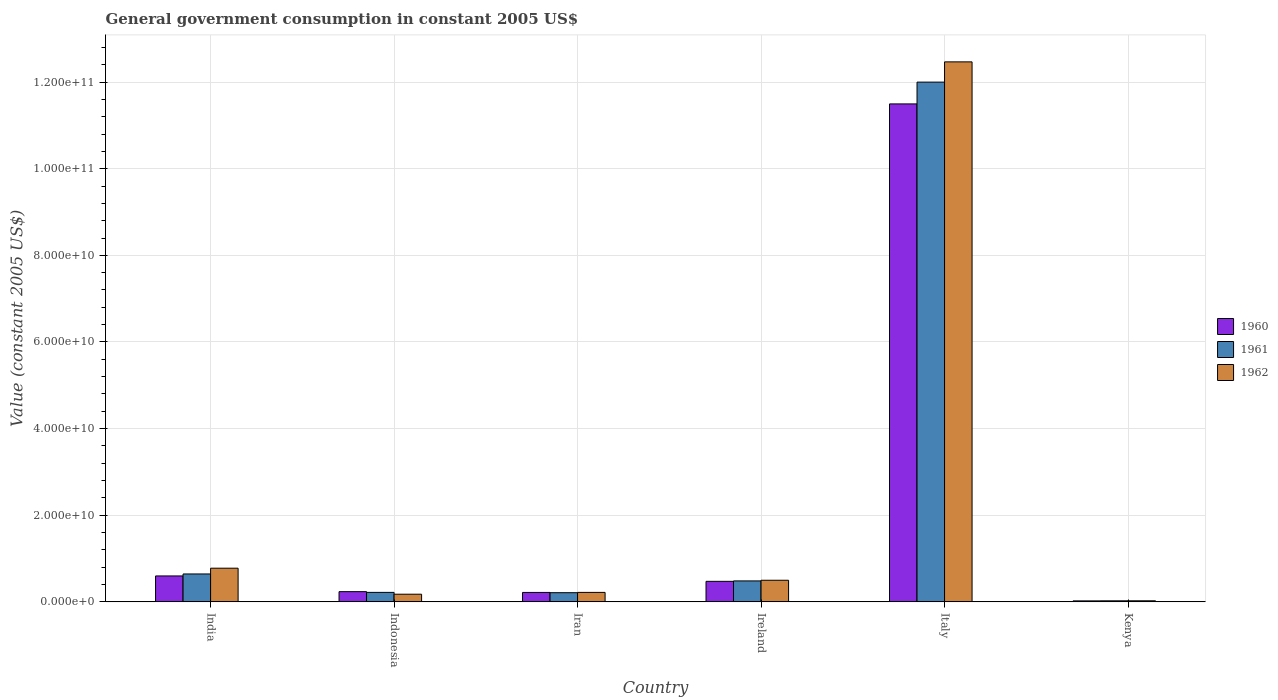How many different coloured bars are there?
Offer a very short reply. 3. How many groups of bars are there?
Your answer should be very brief. 6. Are the number of bars on each tick of the X-axis equal?
Your answer should be very brief. Yes. What is the label of the 4th group of bars from the left?
Keep it short and to the point. Ireland. In how many cases, is the number of bars for a given country not equal to the number of legend labels?
Your response must be concise. 0. What is the government conusmption in 1960 in Kenya?
Your response must be concise. 2.28e+08. Across all countries, what is the maximum government conusmption in 1962?
Offer a terse response. 1.25e+11. Across all countries, what is the minimum government conusmption in 1960?
Offer a terse response. 2.28e+08. In which country was the government conusmption in 1960 maximum?
Offer a terse response. Italy. In which country was the government conusmption in 1960 minimum?
Make the answer very short. Kenya. What is the total government conusmption in 1962 in the graph?
Your response must be concise. 1.42e+11. What is the difference between the government conusmption in 1960 in Iran and that in Ireland?
Your response must be concise. -2.56e+09. What is the difference between the government conusmption in 1962 in Kenya and the government conusmption in 1961 in Ireland?
Offer a terse response. -4.59e+09. What is the average government conusmption in 1962 per country?
Give a very brief answer. 2.36e+1. What is the difference between the government conusmption of/in 1960 and government conusmption of/in 1962 in Italy?
Your answer should be compact. -9.70e+09. What is the ratio of the government conusmption in 1961 in Iran to that in Ireland?
Your answer should be very brief. 0.44. Is the government conusmption in 1961 in Ireland less than that in Kenya?
Offer a terse response. No. Is the difference between the government conusmption in 1960 in India and Italy greater than the difference between the government conusmption in 1962 in India and Italy?
Your answer should be compact. Yes. What is the difference between the highest and the second highest government conusmption in 1961?
Ensure brevity in your answer.  1.14e+11. What is the difference between the highest and the lowest government conusmption in 1960?
Keep it short and to the point. 1.15e+11. In how many countries, is the government conusmption in 1961 greater than the average government conusmption in 1961 taken over all countries?
Make the answer very short. 1. Are all the bars in the graph horizontal?
Your response must be concise. No. What is the difference between two consecutive major ticks on the Y-axis?
Offer a very short reply. 2.00e+1. Does the graph contain grids?
Give a very brief answer. Yes. Where does the legend appear in the graph?
Your answer should be compact. Center right. How many legend labels are there?
Your answer should be compact. 3. What is the title of the graph?
Make the answer very short. General government consumption in constant 2005 US$. What is the label or title of the X-axis?
Keep it short and to the point. Country. What is the label or title of the Y-axis?
Make the answer very short. Value (constant 2005 US$). What is the Value (constant 2005 US$) of 1960 in India?
Offer a terse response. 5.99e+09. What is the Value (constant 2005 US$) of 1961 in India?
Provide a succinct answer. 6.44e+09. What is the Value (constant 2005 US$) of 1962 in India?
Make the answer very short. 7.77e+09. What is the Value (constant 2005 US$) of 1960 in Indonesia?
Keep it short and to the point. 2.36e+09. What is the Value (constant 2005 US$) in 1961 in Indonesia?
Your answer should be compact. 2.19e+09. What is the Value (constant 2005 US$) of 1962 in Indonesia?
Ensure brevity in your answer.  1.77e+09. What is the Value (constant 2005 US$) of 1960 in Iran?
Your response must be concise. 2.18e+09. What is the Value (constant 2005 US$) of 1961 in Iran?
Provide a short and direct response. 2.12e+09. What is the Value (constant 2005 US$) of 1962 in Iran?
Provide a succinct answer. 2.19e+09. What is the Value (constant 2005 US$) in 1960 in Ireland?
Give a very brief answer. 4.74e+09. What is the Value (constant 2005 US$) of 1961 in Ireland?
Make the answer very short. 4.84e+09. What is the Value (constant 2005 US$) in 1962 in Ireland?
Provide a short and direct response. 4.99e+09. What is the Value (constant 2005 US$) of 1960 in Italy?
Your answer should be very brief. 1.15e+11. What is the Value (constant 2005 US$) in 1961 in Italy?
Provide a short and direct response. 1.20e+11. What is the Value (constant 2005 US$) in 1962 in Italy?
Ensure brevity in your answer.  1.25e+11. What is the Value (constant 2005 US$) of 1960 in Kenya?
Offer a terse response. 2.28e+08. What is the Value (constant 2005 US$) in 1961 in Kenya?
Keep it short and to the point. 2.44e+08. What is the Value (constant 2005 US$) of 1962 in Kenya?
Keep it short and to the point. 2.50e+08. Across all countries, what is the maximum Value (constant 2005 US$) in 1960?
Offer a terse response. 1.15e+11. Across all countries, what is the maximum Value (constant 2005 US$) of 1961?
Your response must be concise. 1.20e+11. Across all countries, what is the maximum Value (constant 2005 US$) of 1962?
Provide a succinct answer. 1.25e+11. Across all countries, what is the minimum Value (constant 2005 US$) of 1960?
Your response must be concise. 2.28e+08. Across all countries, what is the minimum Value (constant 2005 US$) in 1961?
Offer a very short reply. 2.44e+08. Across all countries, what is the minimum Value (constant 2005 US$) in 1962?
Your answer should be compact. 2.50e+08. What is the total Value (constant 2005 US$) in 1960 in the graph?
Provide a short and direct response. 1.30e+11. What is the total Value (constant 2005 US$) in 1961 in the graph?
Give a very brief answer. 1.36e+11. What is the total Value (constant 2005 US$) of 1962 in the graph?
Keep it short and to the point. 1.42e+11. What is the difference between the Value (constant 2005 US$) of 1960 in India and that in Indonesia?
Make the answer very short. 3.63e+09. What is the difference between the Value (constant 2005 US$) of 1961 in India and that in Indonesia?
Your answer should be very brief. 4.25e+09. What is the difference between the Value (constant 2005 US$) of 1962 in India and that in Indonesia?
Provide a succinct answer. 6.01e+09. What is the difference between the Value (constant 2005 US$) of 1960 in India and that in Iran?
Offer a very short reply. 3.81e+09. What is the difference between the Value (constant 2005 US$) of 1961 in India and that in Iran?
Your answer should be very brief. 4.32e+09. What is the difference between the Value (constant 2005 US$) of 1962 in India and that in Iran?
Your answer should be compact. 5.59e+09. What is the difference between the Value (constant 2005 US$) of 1960 in India and that in Ireland?
Ensure brevity in your answer.  1.25e+09. What is the difference between the Value (constant 2005 US$) of 1961 in India and that in Ireland?
Ensure brevity in your answer.  1.60e+09. What is the difference between the Value (constant 2005 US$) in 1962 in India and that in Ireland?
Give a very brief answer. 2.78e+09. What is the difference between the Value (constant 2005 US$) in 1960 in India and that in Italy?
Provide a short and direct response. -1.09e+11. What is the difference between the Value (constant 2005 US$) of 1961 in India and that in Italy?
Your response must be concise. -1.14e+11. What is the difference between the Value (constant 2005 US$) of 1962 in India and that in Italy?
Your response must be concise. -1.17e+11. What is the difference between the Value (constant 2005 US$) in 1960 in India and that in Kenya?
Make the answer very short. 5.76e+09. What is the difference between the Value (constant 2005 US$) in 1961 in India and that in Kenya?
Your answer should be very brief. 6.20e+09. What is the difference between the Value (constant 2005 US$) in 1962 in India and that in Kenya?
Offer a terse response. 7.52e+09. What is the difference between the Value (constant 2005 US$) of 1960 in Indonesia and that in Iran?
Your response must be concise. 1.79e+08. What is the difference between the Value (constant 2005 US$) of 1961 in Indonesia and that in Iran?
Offer a very short reply. 7.22e+07. What is the difference between the Value (constant 2005 US$) in 1962 in Indonesia and that in Iran?
Ensure brevity in your answer.  -4.19e+08. What is the difference between the Value (constant 2005 US$) in 1960 in Indonesia and that in Ireland?
Offer a very short reply. -2.38e+09. What is the difference between the Value (constant 2005 US$) in 1961 in Indonesia and that in Ireland?
Offer a very short reply. -2.65e+09. What is the difference between the Value (constant 2005 US$) in 1962 in Indonesia and that in Ireland?
Keep it short and to the point. -3.22e+09. What is the difference between the Value (constant 2005 US$) of 1960 in Indonesia and that in Italy?
Give a very brief answer. -1.13e+11. What is the difference between the Value (constant 2005 US$) of 1961 in Indonesia and that in Italy?
Your answer should be very brief. -1.18e+11. What is the difference between the Value (constant 2005 US$) in 1962 in Indonesia and that in Italy?
Your answer should be compact. -1.23e+11. What is the difference between the Value (constant 2005 US$) in 1960 in Indonesia and that in Kenya?
Keep it short and to the point. 2.13e+09. What is the difference between the Value (constant 2005 US$) of 1961 in Indonesia and that in Kenya?
Offer a terse response. 1.95e+09. What is the difference between the Value (constant 2005 US$) of 1962 in Indonesia and that in Kenya?
Make the answer very short. 1.52e+09. What is the difference between the Value (constant 2005 US$) in 1960 in Iran and that in Ireland?
Your answer should be compact. -2.56e+09. What is the difference between the Value (constant 2005 US$) in 1961 in Iran and that in Ireland?
Your answer should be compact. -2.72e+09. What is the difference between the Value (constant 2005 US$) of 1962 in Iran and that in Ireland?
Ensure brevity in your answer.  -2.80e+09. What is the difference between the Value (constant 2005 US$) of 1960 in Iran and that in Italy?
Ensure brevity in your answer.  -1.13e+11. What is the difference between the Value (constant 2005 US$) of 1961 in Iran and that in Italy?
Provide a succinct answer. -1.18e+11. What is the difference between the Value (constant 2005 US$) in 1962 in Iran and that in Italy?
Ensure brevity in your answer.  -1.22e+11. What is the difference between the Value (constant 2005 US$) in 1960 in Iran and that in Kenya?
Provide a succinct answer. 1.95e+09. What is the difference between the Value (constant 2005 US$) of 1961 in Iran and that in Kenya?
Your answer should be very brief. 1.87e+09. What is the difference between the Value (constant 2005 US$) in 1962 in Iran and that in Kenya?
Offer a terse response. 1.94e+09. What is the difference between the Value (constant 2005 US$) in 1960 in Ireland and that in Italy?
Give a very brief answer. -1.10e+11. What is the difference between the Value (constant 2005 US$) of 1961 in Ireland and that in Italy?
Offer a terse response. -1.15e+11. What is the difference between the Value (constant 2005 US$) of 1962 in Ireland and that in Italy?
Offer a terse response. -1.20e+11. What is the difference between the Value (constant 2005 US$) of 1960 in Ireland and that in Kenya?
Provide a short and direct response. 4.51e+09. What is the difference between the Value (constant 2005 US$) of 1961 in Ireland and that in Kenya?
Provide a succinct answer. 4.60e+09. What is the difference between the Value (constant 2005 US$) in 1962 in Ireland and that in Kenya?
Provide a succinct answer. 4.74e+09. What is the difference between the Value (constant 2005 US$) of 1960 in Italy and that in Kenya?
Your answer should be compact. 1.15e+11. What is the difference between the Value (constant 2005 US$) of 1961 in Italy and that in Kenya?
Your response must be concise. 1.20e+11. What is the difference between the Value (constant 2005 US$) in 1962 in Italy and that in Kenya?
Your response must be concise. 1.24e+11. What is the difference between the Value (constant 2005 US$) of 1960 in India and the Value (constant 2005 US$) of 1961 in Indonesia?
Offer a very short reply. 3.80e+09. What is the difference between the Value (constant 2005 US$) in 1960 in India and the Value (constant 2005 US$) in 1962 in Indonesia?
Your answer should be very brief. 4.22e+09. What is the difference between the Value (constant 2005 US$) in 1961 in India and the Value (constant 2005 US$) in 1962 in Indonesia?
Provide a succinct answer. 4.67e+09. What is the difference between the Value (constant 2005 US$) in 1960 in India and the Value (constant 2005 US$) in 1961 in Iran?
Make the answer very short. 3.87e+09. What is the difference between the Value (constant 2005 US$) in 1960 in India and the Value (constant 2005 US$) in 1962 in Iran?
Your answer should be very brief. 3.80e+09. What is the difference between the Value (constant 2005 US$) of 1961 in India and the Value (constant 2005 US$) of 1962 in Iran?
Make the answer very short. 4.26e+09. What is the difference between the Value (constant 2005 US$) of 1960 in India and the Value (constant 2005 US$) of 1961 in Ireland?
Provide a succinct answer. 1.15e+09. What is the difference between the Value (constant 2005 US$) in 1960 in India and the Value (constant 2005 US$) in 1962 in Ireland?
Make the answer very short. 9.96e+08. What is the difference between the Value (constant 2005 US$) in 1961 in India and the Value (constant 2005 US$) in 1962 in Ireland?
Your answer should be very brief. 1.45e+09. What is the difference between the Value (constant 2005 US$) in 1960 in India and the Value (constant 2005 US$) in 1961 in Italy?
Keep it short and to the point. -1.14e+11. What is the difference between the Value (constant 2005 US$) in 1960 in India and the Value (constant 2005 US$) in 1962 in Italy?
Give a very brief answer. -1.19e+11. What is the difference between the Value (constant 2005 US$) in 1961 in India and the Value (constant 2005 US$) in 1962 in Italy?
Your answer should be compact. -1.18e+11. What is the difference between the Value (constant 2005 US$) in 1960 in India and the Value (constant 2005 US$) in 1961 in Kenya?
Offer a very short reply. 5.74e+09. What is the difference between the Value (constant 2005 US$) of 1960 in India and the Value (constant 2005 US$) of 1962 in Kenya?
Provide a short and direct response. 5.74e+09. What is the difference between the Value (constant 2005 US$) in 1961 in India and the Value (constant 2005 US$) in 1962 in Kenya?
Ensure brevity in your answer.  6.19e+09. What is the difference between the Value (constant 2005 US$) in 1960 in Indonesia and the Value (constant 2005 US$) in 1961 in Iran?
Make the answer very short. 2.41e+08. What is the difference between the Value (constant 2005 US$) of 1960 in Indonesia and the Value (constant 2005 US$) of 1962 in Iran?
Your response must be concise. 1.72e+08. What is the difference between the Value (constant 2005 US$) in 1961 in Indonesia and the Value (constant 2005 US$) in 1962 in Iran?
Your answer should be compact. 2.74e+06. What is the difference between the Value (constant 2005 US$) of 1960 in Indonesia and the Value (constant 2005 US$) of 1961 in Ireland?
Your answer should be very brief. -2.48e+09. What is the difference between the Value (constant 2005 US$) in 1960 in Indonesia and the Value (constant 2005 US$) in 1962 in Ireland?
Provide a succinct answer. -2.63e+09. What is the difference between the Value (constant 2005 US$) of 1961 in Indonesia and the Value (constant 2005 US$) of 1962 in Ireland?
Keep it short and to the point. -2.80e+09. What is the difference between the Value (constant 2005 US$) of 1960 in Indonesia and the Value (constant 2005 US$) of 1961 in Italy?
Offer a very short reply. -1.18e+11. What is the difference between the Value (constant 2005 US$) of 1960 in Indonesia and the Value (constant 2005 US$) of 1962 in Italy?
Provide a succinct answer. -1.22e+11. What is the difference between the Value (constant 2005 US$) of 1961 in Indonesia and the Value (constant 2005 US$) of 1962 in Italy?
Keep it short and to the point. -1.22e+11. What is the difference between the Value (constant 2005 US$) in 1960 in Indonesia and the Value (constant 2005 US$) in 1961 in Kenya?
Your response must be concise. 2.12e+09. What is the difference between the Value (constant 2005 US$) in 1960 in Indonesia and the Value (constant 2005 US$) in 1962 in Kenya?
Your answer should be compact. 2.11e+09. What is the difference between the Value (constant 2005 US$) of 1961 in Indonesia and the Value (constant 2005 US$) of 1962 in Kenya?
Provide a short and direct response. 1.94e+09. What is the difference between the Value (constant 2005 US$) in 1960 in Iran and the Value (constant 2005 US$) in 1961 in Ireland?
Give a very brief answer. -2.66e+09. What is the difference between the Value (constant 2005 US$) in 1960 in Iran and the Value (constant 2005 US$) in 1962 in Ireland?
Give a very brief answer. -2.81e+09. What is the difference between the Value (constant 2005 US$) of 1961 in Iran and the Value (constant 2005 US$) of 1962 in Ireland?
Ensure brevity in your answer.  -2.87e+09. What is the difference between the Value (constant 2005 US$) of 1960 in Iran and the Value (constant 2005 US$) of 1961 in Italy?
Make the answer very short. -1.18e+11. What is the difference between the Value (constant 2005 US$) in 1960 in Iran and the Value (constant 2005 US$) in 1962 in Italy?
Provide a short and direct response. -1.22e+11. What is the difference between the Value (constant 2005 US$) in 1961 in Iran and the Value (constant 2005 US$) in 1962 in Italy?
Offer a terse response. -1.23e+11. What is the difference between the Value (constant 2005 US$) of 1960 in Iran and the Value (constant 2005 US$) of 1961 in Kenya?
Your answer should be compact. 1.94e+09. What is the difference between the Value (constant 2005 US$) in 1960 in Iran and the Value (constant 2005 US$) in 1962 in Kenya?
Your answer should be very brief. 1.93e+09. What is the difference between the Value (constant 2005 US$) of 1961 in Iran and the Value (constant 2005 US$) of 1962 in Kenya?
Offer a terse response. 1.87e+09. What is the difference between the Value (constant 2005 US$) of 1960 in Ireland and the Value (constant 2005 US$) of 1961 in Italy?
Your response must be concise. -1.15e+11. What is the difference between the Value (constant 2005 US$) of 1960 in Ireland and the Value (constant 2005 US$) of 1962 in Italy?
Offer a very short reply. -1.20e+11. What is the difference between the Value (constant 2005 US$) of 1961 in Ireland and the Value (constant 2005 US$) of 1962 in Italy?
Offer a very short reply. -1.20e+11. What is the difference between the Value (constant 2005 US$) of 1960 in Ireland and the Value (constant 2005 US$) of 1961 in Kenya?
Your answer should be compact. 4.50e+09. What is the difference between the Value (constant 2005 US$) of 1960 in Ireland and the Value (constant 2005 US$) of 1962 in Kenya?
Make the answer very short. 4.49e+09. What is the difference between the Value (constant 2005 US$) in 1961 in Ireland and the Value (constant 2005 US$) in 1962 in Kenya?
Your answer should be compact. 4.59e+09. What is the difference between the Value (constant 2005 US$) in 1960 in Italy and the Value (constant 2005 US$) in 1961 in Kenya?
Offer a terse response. 1.15e+11. What is the difference between the Value (constant 2005 US$) in 1960 in Italy and the Value (constant 2005 US$) in 1962 in Kenya?
Give a very brief answer. 1.15e+11. What is the difference between the Value (constant 2005 US$) in 1961 in Italy and the Value (constant 2005 US$) in 1962 in Kenya?
Your answer should be compact. 1.20e+11. What is the average Value (constant 2005 US$) in 1960 per country?
Keep it short and to the point. 2.17e+1. What is the average Value (constant 2005 US$) in 1961 per country?
Offer a terse response. 2.26e+1. What is the average Value (constant 2005 US$) in 1962 per country?
Offer a terse response. 2.36e+1. What is the difference between the Value (constant 2005 US$) of 1960 and Value (constant 2005 US$) of 1961 in India?
Provide a succinct answer. -4.56e+08. What is the difference between the Value (constant 2005 US$) in 1960 and Value (constant 2005 US$) in 1962 in India?
Offer a terse response. -1.79e+09. What is the difference between the Value (constant 2005 US$) of 1961 and Value (constant 2005 US$) of 1962 in India?
Your answer should be very brief. -1.33e+09. What is the difference between the Value (constant 2005 US$) in 1960 and Value (constant 2005 US$) in 1961 in Indonesia?
Make the answer very short. 1.69e+08. What is the difference between the Value (constant 2005 US$) in 1960 and Value (constant 2005 US$) in 1962 in Indonesia?
Provide a succinct answer. 5.91e+08. What is the difference between the Value (constant 2005 US$) in 1961 and Value (constant 2005 US$) in 1962 in Indonesia?
Keep it short and to the point. 4.22e+08. What is the difference between the Value (constant 2005 US$) in 1960 and Value (constant 2005 US$) in 1961 in Iran?
Make the answer very short. 6.20e+07. What is the difference between the Value (constant 2005 US$) in 1960 and Value (constant 2005 US$) in 1962 in Iran?
Offer a terse response. -7.44e+06. What is the difference between the Value (constant 2005 US$) in 1961 and Value (constant 2005 US$) in 1962 in Iran?
Offer a very short reply. -6.95e+07. What is the difference between the Value (constant 2005 US$) of 1960 and Value (constant 2005 US$) of 1961 in Ireland?
Keep it short and to the point. -9.93e+07. What is the difference between the Value (constant 2005 US$) of 1960 and Value (constant 2005 US$) of 1962 in Ireland?
Your response must be concise. -2.51e+08. What is the difference between the Value (constant 2005 US$) in 1961 and Value (constant 2005 US$) in 1962 in Ireland?
Give a very brief answer. -1.51e+08. What is the difference between the Value (constant 2005 US$) in 1960 and Value (constant 2005 US$) in 1961 in Italy?
Provide a succinct answer. -5.03e+09. What is the difference between the Value (constant 2005 US$) of 1960 and Value (constant 2005 US$) of 1962 in Italy?
Offer a very short reply. -9.70e+09. What is the difference between the Value (constant 2005 US$) of 1961 and Value (constant 2005 US$) of 1962 in Italy?
Offer a terse response. -4.67e+09. What is the difference between the Value (constant 2005 US$) in 1960 and Value (constant 2005 US$) in 1961 in Kenya?
Provide a short and direct response. -1.55e+07. What is the difference between the Value (constant 2005 US$) of 1960 and Value (constant 2005 US$) of 1962 in Kenya?
Make the answer very short. -2.21e+07. What is the difference between the Value (constant 2005 US$) of 1961 and Value (constant 2005 US$) of 1962 in Kenya?
Give a very brief answer. -6.66e+06. What is the ratio of the Value (constant 2005 US$) of 1960 in India to that in Indonesia?
Provide a succinct answer. 2.54. What is the ratio of the Value (constant 2005 US$) in 1961 in India to that in Indonesia?
Give a very brief answer. 2.94. What is the ratio of the Value (constant 2005 US$) in 1962 in India to that in Indonesia?
Offer a terse response. 4.4. What is the ratio of the Value (constant 2005 US$) in 1960 in India to that in Iran?
Ensure brevity in your answer.  2.75. What is the ratio of the Value (constant 2005 US$) in 1961 in India to that in Iran?
Your response must be concise. 3.04. What is the ratio of the Value (constant 2005 US$) in 1962 in India to that in Iran?
Ensure brevity in your answer.  3.55. What is the ratio of the Value (constant 2005 US$) of 1960 in India to that in Ireland?
Your answer should be compact. 1.26. What is the ratio of the Value (constant 2005 US$) of 1961 in India to that in Ireland?
Provide a short and direct response. 1.33. What is the ratio of the Value (constant 2005 US$) of 1962 in India to that in Ireland?
Keep it short and to the point. 1.56. What is the ratio of the Value (constant 2005 US$) in 1960 in India to that in Italy?
Offer a very short reply. 0.05. What is the ratio of the Value (constant 2005 US$) of 1961 in India to that in Italy?
Your answer should be very brief. 0.05. What is the ratio of the Value (constant 2005 US$) of 1962 in India to that in Italy?
Offer a very short reply. 0.06. What is the ratio of the Value (constant 2005 US$) of 1960 in India to that in Kenya?
Give a very brief answer. 26.22. What is the ratio of the Value (constant 2005 US$) in 1961 in India to that in Kenya?
Offer a terse response. 26.43. What is the ratio of the Value (constant 2005 US$) of 1962 in India to that in Kenya?
Offer a terse response. 31.04. What is the ratio of the Value (constant 2005 US$) of 1960 in Indonesia to that in Iran?
Keep it short and to the point. 1.08. What is the ratio of the Value (constant 2005 US$) in 1961 in Indonesia to that in Iran?
Provide a short and direct response. 1.03. What is the ratio of the Value (constant 2005 US$) of 1962 in Indonesia to that in Iran?
Offer a very short reply. 0.81. What is the ratio of the Value (constant 2005 US$) in 1960 in Indonesia to that in Ireland?
Ensure brevity in your answer.  0.5. What is the ratio of the Value (constant 2005 US$) in 1961 in Indonesia to that in Ireland?
Provide a succinct answer. 0.45. What is the ratio of the Value (constant 2005 US$) of 1962 in Indonesia to that in Ireland?
Offer a very short reply. 0.35. What is the ratio of the Value (constant 2005 US$) in 1960 in Indonesia to that in Italy?
Keep it short and to the point. 0.02. What is the ratio of the Value (constant 2005 US$) in 1961 in Indonesia to that in Italy?
Your answer should be very brief. 0.02. What is the ratio of the Value (constant 2005 US$) of 1962 in Indonesia to that in Italy?
Make the answer very short. 0.01. What is the ratio of the Value (constant 2005 US$) of 1960 in Indonesia to that in Kenya?
Offer a terse response. 10.33. What is the ratio of the Value (constant 2005 US$) of 1961 in Indonesia to that in Kenya?
Your response must be concise. 8.99. What is the ratio of the Value (constant 2005 US$) of 1962 in Indonesia to that in Kenya?
Your answer should be compact. 7.06. What is the ratio of the Value (constant 2005 US$) of 1960 in Iran to that in Ireland?
Provide a short and direct response. 0.46. What is the ratio of the Value (constant 2005 US$) in 1961 in Iran to that in Ireland?
Provide a succinct answer. 0.44. What is the ratio of the Value (constant 2005 US$) in 1962 in Iran to that in Ireland?
Offer a terse response. 0.44. What is the ratio of the Value (constant 2005 US$) of 1960 in Iran to that in Italy?
Ensure brevity in your answer.  0.02. What is the ratio of the Value (constant 2005 US$) of 1961 in Iran to that in Italy?
Keep it short and to the point. 0.02. What is the ratio of the Value (constant 2005 US$) in 1962 in Iran to that in Italy?
Keep it short and to the point. 0.02. What is the ratio of the Value (constant 2005 US$) of 1960 in Iran to that in Kenya?
Make the answer very short. 9.55. What is the ratio of the Value (constant 2005 US$) in 1961 in Iran to that in Kenya?
Offer a terse response. 8.69. What is the ratio of the Value (constant 2005 US$) in 1962 in Iran to that in Kenya?
Offer a very short reply. 8.74. What is the ratio of the Value (constant 2005 US$) in 1960 in Ireland to that in Italy?
Ensure brevity in your answer.  0.04. What is the ratio of the Value (constant 2005 US$) of 1961 in Ireland to that in Italy?
Ensure brevity in your answer.  0.04. What is the ratio of the Value (constant 2005 US$) of 1960 in Ireland to that in Kenya?
Ensure brevity in your answer.  20.76. What is the ratio of the Value (constant 2005 US$) in 1961 in Ireland to that in Kenya?
Ensure brevity in your answer.  19.85. What is the ratio of the Value (constant 2005 US$) in 1962 in Ireland to that in Kenya?
Your answer should be compact. 19.93. What is the ratio of the Value (constant 2005 US$) in 1960 in Italy to that in Kenya?
Your answer should be very brief. 503.61. What is the ratio of the Value (constant 2005 US$) in 1961 in Italy to that in Kenya?
Provide a succinct answer. 492.25. What is the ratio of the Value (constant 2005 US$) of 1962 in Italy to that in Kenya?
Your answer should be very brief. 497.82. What is the difference between the highest and the second highest Value (constant 2005 US$) of 1960?
Offer a very short reply. 1.09e+11. What is the difference between the highest and the second highest Value (constant 2005 US$) of 1961?
Your answer should be very brief. 1.14e+11. What is the difference between the highest and the second highest Value (constant 2005 US$) in 1962?
Your response must be concise. 1.17e+11. What is the difference between the highest and the lowest Value (constant 2005 US$) in 1960?
Keep it short and to the point. 1.15e+11. What is the difference between the highest and the lowest Value (constant 2005 US$) in 1961?
Your answer should be compact. 1.20e+11. What is the difference between the highest and the lowest Value (constant 2005 US$) in 1962?
Provide a short and direct response. 1.24e+11. 